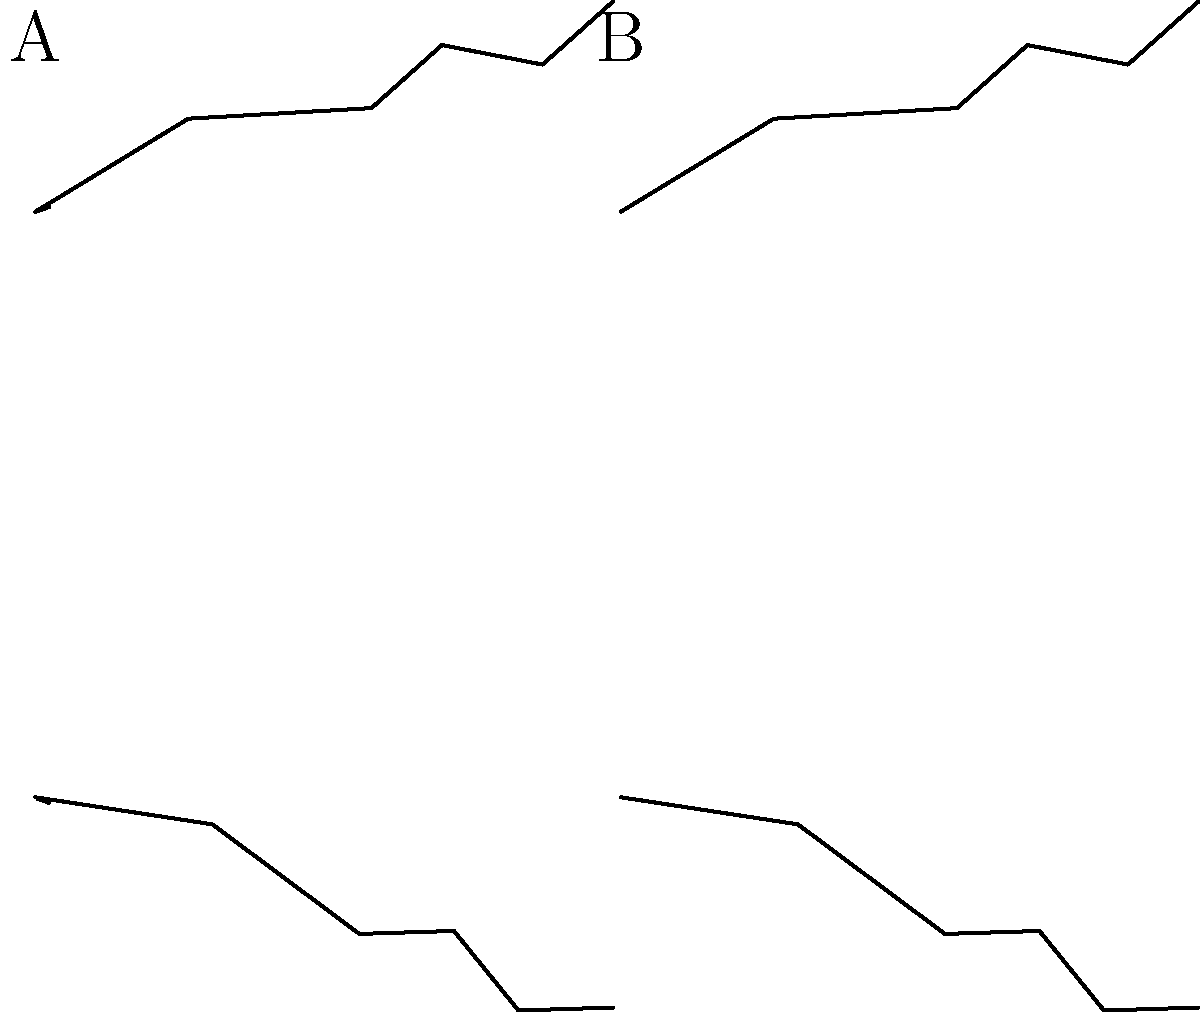As an entomologist, you're examining wing structure diagrams of different insect orders. The image shows two pairs of wings labeled A and B. Based on the presence or absence of cross veins, which insect order is most likely represented by wing pair A? To identify the insect order represented by wing pair A, let's analyze the wing structure step-by-step:

1. Observe the wing pairs:
   - Wing pair A (left) has visible cross veins connecting the main veins.
   - Wing pair B (right) lacks cross veins, showing only main veins.

2. Consider the significance of cross veins:
   - Cross veins provide additional structural support and improve flight maneuverability.
   - They are characteristic of certain insect orders.

3. Identify orders with prominent cross veins:
   - Odonata (dragonflies and damselflies) have numerous cross veins.
   - Neuroptera (lacewings) also display a network of cross veins.

4. Eliminate orders without cross veins:
   - Lepidoptera (butterflies and moths) typically lack visible cross veins.
   - Diptera (flies) generally have simpler wing venation without cross veins.

5. Consider the overall wing shape and arrangement:
   - The wings in pair A are similar in size and shape.
   - This is consistent with the Odonata order.

6. Conclude based on the evidence:
   - The presence of cross veins and the similarity of fore and hind wings strongly suggest the Odonata order.

Therefore, wing pair A most likely represents the insect order Odonata.
Answer: Odonata 